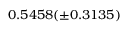<formula> <loc_0><loc_0><loc_500><loc_500>0 . 5 4 5 8 ( \pm 0 . 3 1 3 5 )</formula> 